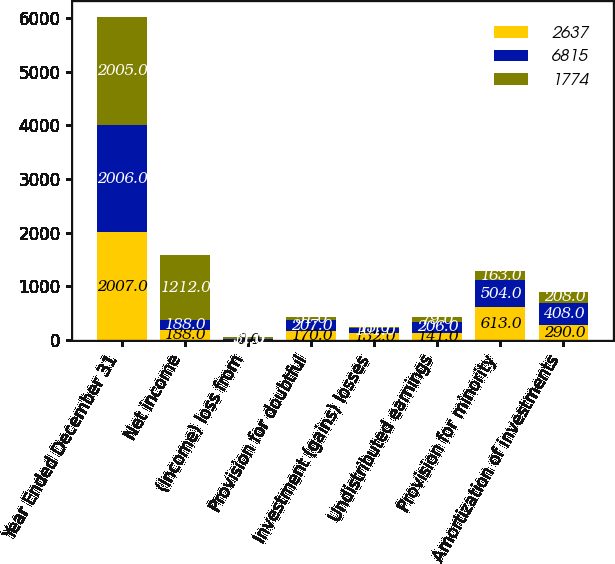Convert chart. <chart><loc_0><loc_0><loc_500><loc_500><stacked_bar_chart><ecel><fcel>Year Ended December 31<fcel>Net income<fcel>(Income) loss from<fcel>Provision for doubtful<fcel>Investment (gains) losses<fcel>Undistributed earnings<fcel>Provision for minority<fcel>Amortization of investments<nl><fcel>2637<fcel>2007<fcel>188<fcel>8<fcel>170<fcel>132<fcel>141<fcel>613<fcel>290<nl><fcel>6815<fcel>2006<fcel>188<fcel>11<fcel>207<fcel>101<fcel>206<fcel>504<fcel>408<nl><fcel>1774<fcel>2005<fcel>1212<fcel>31<fcel>51<fcel>13<fcel>79<fcel>163<fcel>208<nl></chart> 